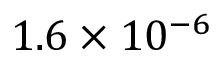Convert formula to latex. <formula><loc_0><loc_0><loc_500><loc_500>1 . 6 \times 1 0 ^ { - 6 }</formula> 